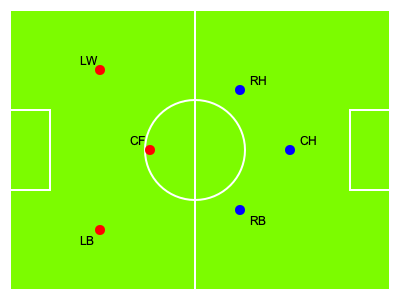In this British field hockey formation, which player is positioned to provide the most direct support to the Centre Forward (CF) in the attacking third? To answer this question, we need to analyze the positions of the players on the field:

1. The red dots represent the attacking team (likely Great Britain), while the blue dots represent the defending team.

2. The positions are labeled as follows:
   - LW: Left Wing
   - CF: Centre Forward
   - LB: Left Back
   - RH: Right Half
   - CH: Centre Half
   - RB: Right Back

3. The Centre Forward (CF) is positioned in the center of the attacking third.

4. To provide direct support to the CF, a player should be positioned nearby and preferably in a more advanced position.

5. Looking at the formation, we can see that the Left Wing (LW) is the closest attacking player to the CF and is positioned slightly ahead.

6. The LW is in an ideal position to make runs, receive passes from the CF, or provide quick passes to the CF, making them the most direct support in the attacking third.

7. The Left Back (LB) is too far back to provide immediate attacking support, while the opposing team's players (blue dots) are not considered for supporting the CF.

Therefore, the Left Wing (LW) is in the best position to provide the most direct support to the Centre Forward in the attacking third.
Answer: Left Wing (LW) 